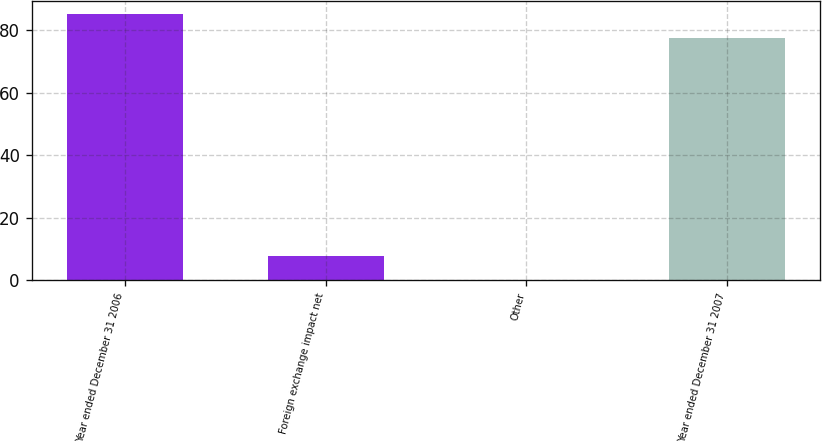Convert chart. <chart><loc_0><loc_0><loc_500><loc_500><bar_chart><fcel>Year ended December 31 2006<fcel>Foreign exchange impact net<fcel>Other<fcel>Year ended December 31 2007<nl><fcel>85.26<fcel>7.86<fcel>0.1<fcel>77.5<nl></chart> 